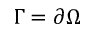<formula> <loc_0><loc_0><loc_500><loc_500>\Gamma = \partial \Omega</formula> 